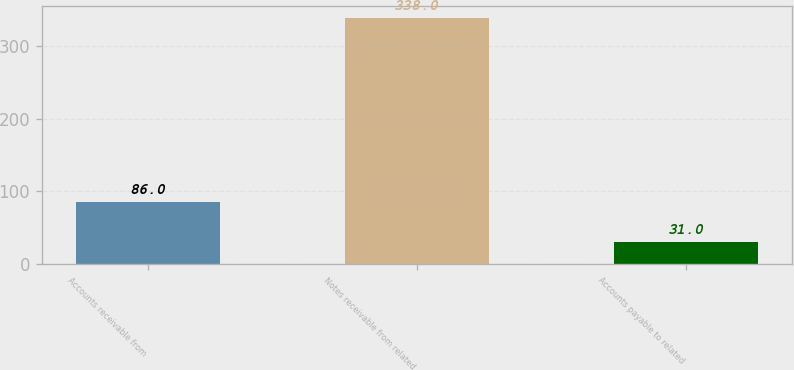Convert chart. <chart><loc_0><loc_0><loc_500><loc_500><bar_chart><fcel>Accounts receivable from<fcel>Notes receivable from related<fcel>Accounts payable to related<nl><fcel>86<fcel>338<fcel>31<nl></chart> 